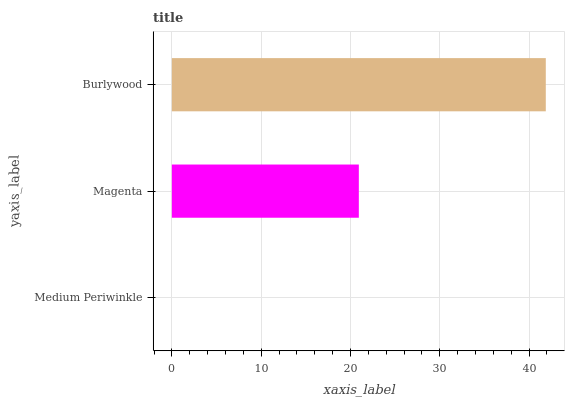Is Medium Periwinkle the minimum?
Answer yes or no. Yes. Is Burlywood the maximum?
Answer yes or no. Yes. Is Magenta the minimum?
Answer yes or no. No. Is Magenta the maximum?
Answer yes or no. No. Is Magenta greater than Medium Periwinkle?
Answer yes or no. Yes. Is Medium Periwinkle less than Magenta?
Answer yes or no. Yes. Is Medium Periwinkle greater than Magenta?
Answer yes or no. No. Is Magenta less than Medium Periwinkle?
Answer yes or no. No. Is Magenta the high median?
Answer yes or no. Yes. Is Magenta the low median?
Answer yes or no. Yes. Is Burlywood the high median?
Answer yes or no. No. Is Medium Periwinkle the low median?
Answer yes or no. No. 